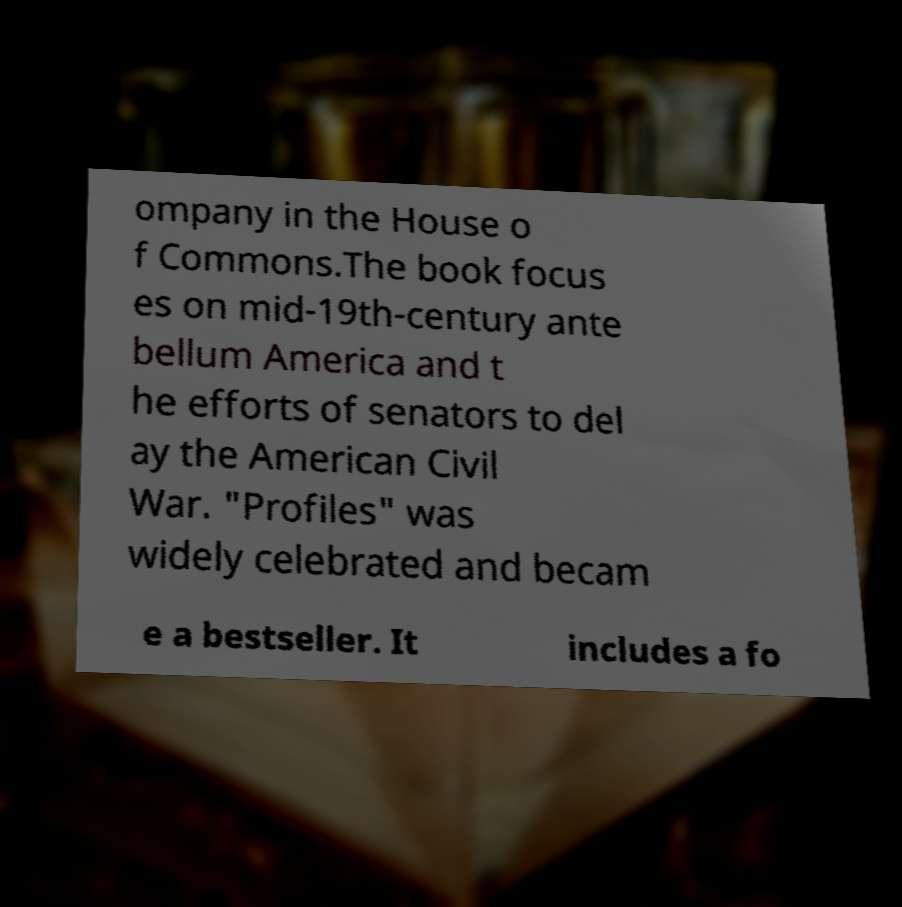Could you assist in decoding the text presented in this image and type it out clearly? ompany in the House o f Commons.The book focus es on mid-19th-century ante bellum America and t he efforts of senators to del ay the American Civil War. "Profiles" was widely celebrated and becam e a bestseller. It includes a fo 